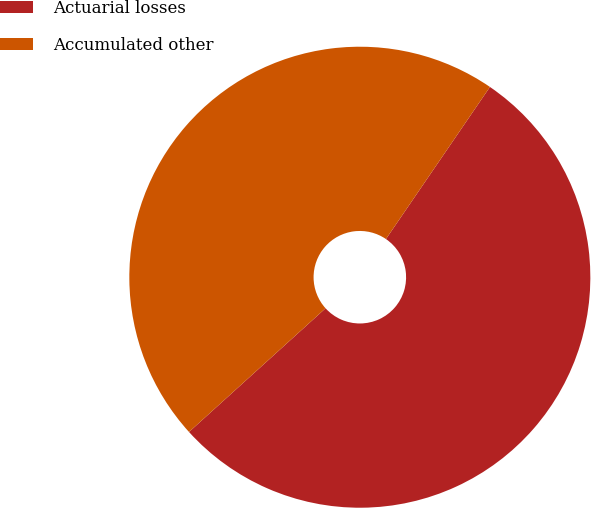Convert chart to OTSL. <chart><loc_0><loc_0><loc_500><loc_500><pie_chart><fcel>Actuarial losses<fcel>Accumulated other<nl><fcel>53.74%<fcel>46.26%<nl></chart> 